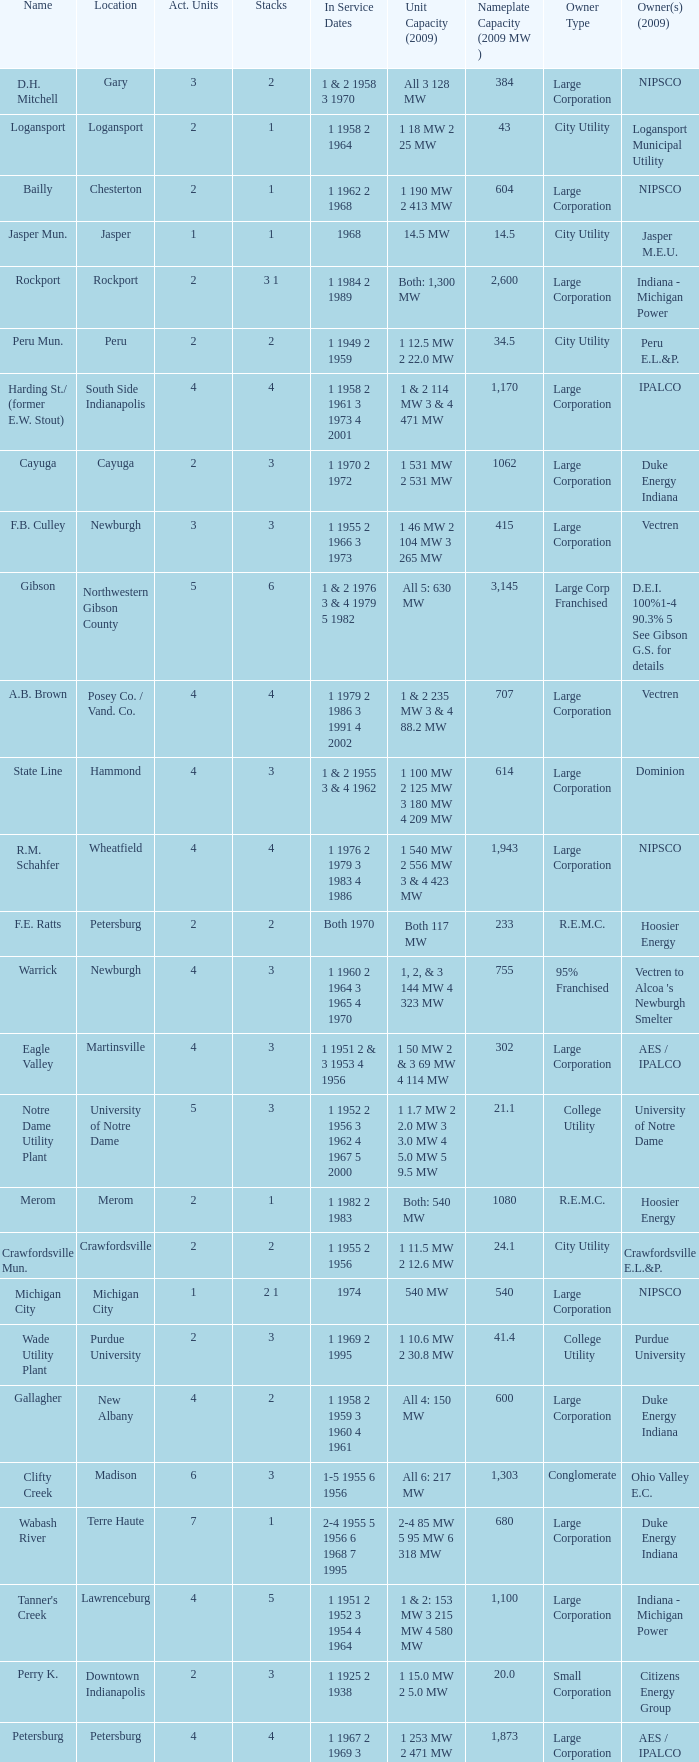Name the number of stacks for 1 & 2 235 mw 3 & 4 88.2 mw 1.0. 